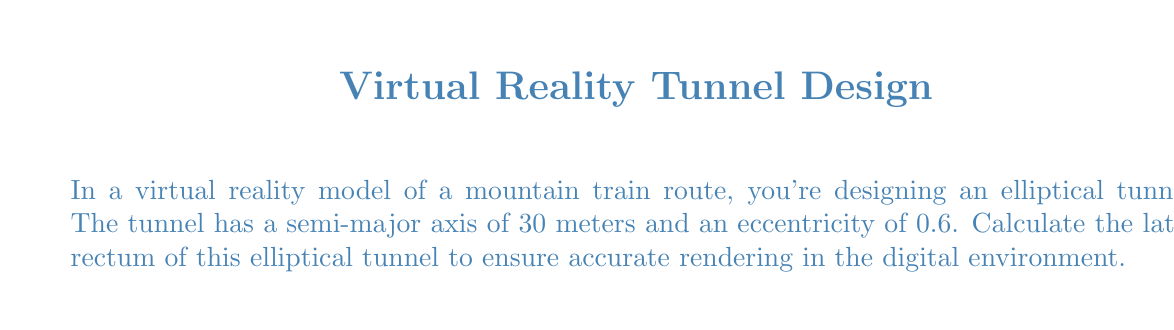Give your solution to this math problem. Let's approach this step-by-step:

1) The latus rectum of an ellipse is the chord that passes through a focus and is perpendicular to the major axis. Its length is given by the formula:

   $$ L = \frac{2b^2}{a} $$

   where $a$ is the semi-major axis and $b$ is the semi-minor axis.

2) We're given that $a = 30$ meters and the eccentricity $e = 0.6$.

3) To find $b$, we can use the relationship between eccentricity, semi-major axis, and semi-minor axis:

   $$ e = \sqrt{1 - \frac{b^2}{a^2}} $$

4) Rearranging this equation:

   $$ b^2 = a^2(1 - e^2) $$

5) Substituting the values:

   $$ b^2 = 30^2(1 - 0.6^2) = 900(1 - 0.36) = 900(0.64) = 576 $$

6) Taking the square root:

   $$ b = \sqrt{576} = 24 \text{ meters} $$

7) Now we can substitute into the latus rectum formula:

   $$ L = \frac{2(24^2)}{30} = \frac{2(576)}{30} = \frac{1152}{30} = 38.4 \text{ meters} $$
Answer: $38.4$ meters 